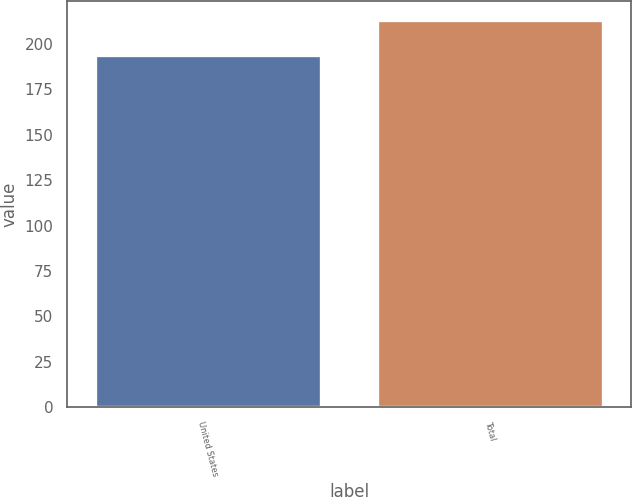Convert chart. <chart><loc_0><loc_0><loc_500><loc_500><bar_chart><fcel>United States<fcel>Total<nl><fcel>194<fcel>213<nl></chart> 